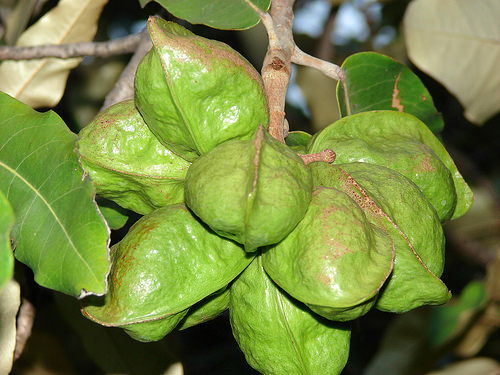<image>
Is there a fruit in the stem? Yes. The fruit is contained within or inside the stem, showing a containment relationship. 